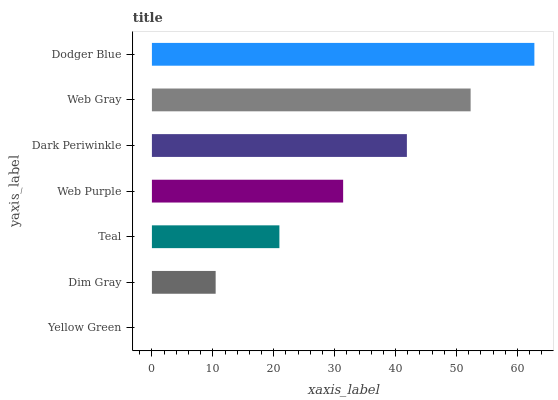Is Yellow Green the minimum?
Answer yes or no. Yes. Is Dodger Blue the maximum?
Answer yes or no. Yes. Is Dim Gray the minimum?
Answer yes or no. No. Is Dim Gray the maximum?
Answer yes or no. No. Is Dim Gray greater than Yellow Green?
Answer yes or no. Yes. Is Yellow Green less than Dim Gray?
Answer yes or no. Yes. Is Yellow Green greater than Dim Gray?
Answer yes or no. No. Is Dim Gray less than Yellow Green?
Answer yes or no. No. Is Web Purple the high median?
Answer yes or no. Yes. Is Web Purple the low median?
Answer yes or no. Yes. Is Dim Gray the high median?
Answer yes or no. No. Is Dark Periwinkle the low median?
Answer yes or no. No. 